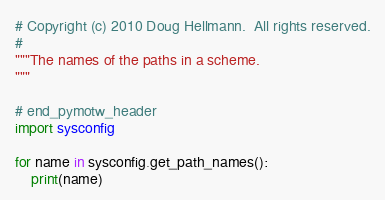Convert code to text. <code><loc_0><loc_0><loc_500><loc_500><_Python_># Copyright (c) 2010 Doug Hellmann.  All rights reserved.
#
"""The names of the paths in a scheme.
"""

# end_pymotw_header
import sysconfig

for name in sysconfig.get_path_names():
    print(name)
</code> 